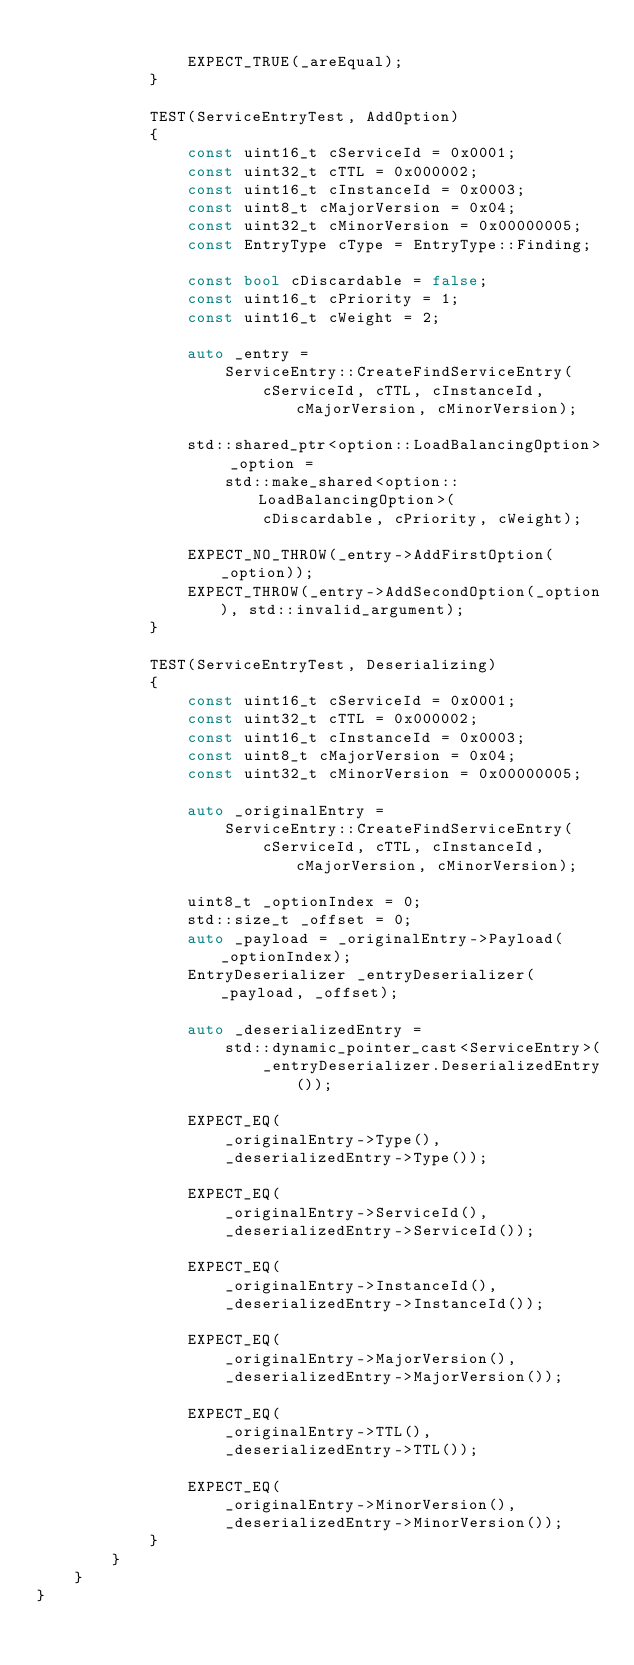<code> <loc_0><loc_0><loc_500><loc_500><_C++_>
                EXPECT_TRUE(_areEqual);
            }

            TEST(ServiceEntryTest, AddOption)
            {
                const uint16_t cServiceId = 0x0001;
                const uint32_t cTTL = 0x000002;
                const uint16_t cInstanceId = 0x0003;
                const uint8_t cMajorVersion = 0x04;
                const uint32_t cMinorVersion = 0x00000005;
                const EntryType cType = EntryType::Finding;

                const bool cDiscardable = false;
                const uint16_t cPriority = 1;
                const uint16_t cWeight = 2;

                auto _entry =
                    ServiceEntry::CreateFindServiceEntry(
                        cServiceId, cTTL, cInstanceId, cMajorVersion, cMinorVersion);

                std::shared_ptr<option::LoadBalancingOption> _option =
                    std::make_shared<option::LoadBalancingOption>(
                        cDiscardable, cPriority, cWeight);

                EXPECT_NO_THROW(_entry->AddFirstOption(_option));
                EXPECT_THROW(_entry->AddSecondOption(_option), std::invalid_argument);
            }

            TEST(ServiceEntryTest, Deserializing)
            {
                const uint16_t cServiceId = 0x0001;
                const uint32_t cTTL = 0x000002;
                const uint16_t cInstanceId = 0x0003;
                const uint8_t cMajorVersion = 0x04;
                const uint32_t cMinorVersion = 0x00000005;

                auto _originalEntry =
                    ServiceEntry::CreateFindServiceEntry(
                        cServiceId, cTTL, cInstanceId, cMajorVersion, cMinorVersion);

                uint8_t _optionIndex = 0;
                std::size_t _offset = 0;
                auto _payload = _originalEntry->Payload(_optionIndex);
                EntryDeserializer _entryDeserializer(_payload, _offset);

                auto _deserializedEntry =
                    std::dynamic_pointer_cast<ServiceEntry>(
                        _entryDeserializer.DeserializedEntry());

                EXPECT_EQ(
                    _originalEntry->Type(),
                    _deserializedEntry->Type());

                EXPECT_EQ(
                    _originalEntry->ServiceId(),
                    _deserializedEntry->ServiceId());

                EXPECT_EQ(
                    _originalEntry->InstanceId(),
                    _deserializedEntry->InstanceId());

                EXPECT_EQ(
                    _originalEntry->MajorVersion(),
                    _deserializedEntry->MajorVersion());

                EXPECT_EQ(
                    _originalEntry->TTL(),
                    _deserializedEntry->TTL());

                EXPECT_EQ(
                    _originalEntry->MinorVersion(),
                    _deserializedEntry->MinorVersion());
            }
        }
    }
}</code> 